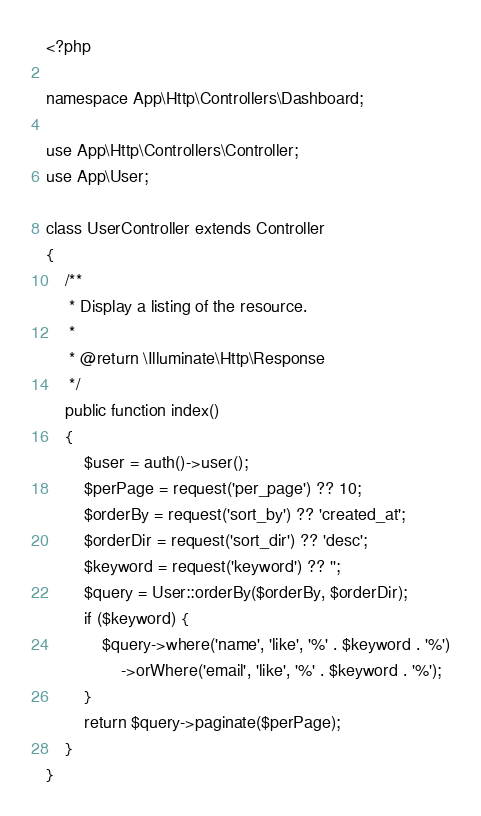<code> <loc_0><loc_0><loc_500><loc_500><_PHP_><?php

namespace App\Http\Controllers\Dashboard;

use App\Http\Controllers\Controller;
use App\User;

class UserController extends Controller
{
    /**
     * Display a listing of the resource.
     *
     * @return \Illuminate\Http\Response
     */
    public function index()
    {
        $user = auth()->user();
        $perPage = request('per_page') ?? 10;
        $orderBy = request('sort_by') ?? 'created_at';
        $orderDir = request('sort_dir') ?? 'desc';
        $keyword = request('keyword') ?? '';
        $query = User::orderBy($orderBy, $orderDir);
        if ($keyword) {
            $query->where('name', 'like', '%' . $keyword . '%')
                ->orWhere('email', 'like', '%' . $keyword . '%');
        }
        return $query->paginate($perPage);
    }
}
</code> 